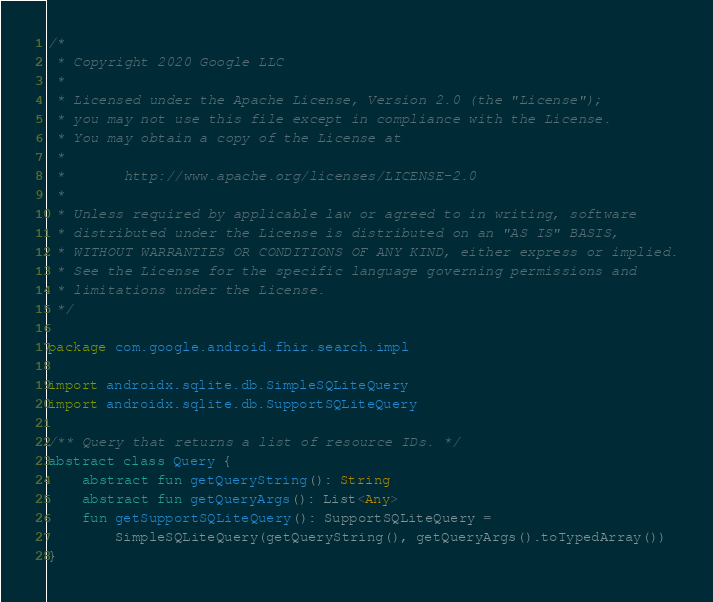Convert code to text. <code><loc_0><loc_0><loc_500><loc_500><_Kotlin_>/*
 * Copyright 2020 Google LLC
 *
 * Licensed under the Apache License, Version 2.0 (the "License");
 * you may not use this file except in compliance with the License.
 * You may obtain a copy of the License at
 *
 *       http://www.apache.org/licenses/LICENSE-2.0
 *
 * Unless required by applicable law or agreed to in writing, software
 * distributed under the License is distributed on an "AS IS" BASIS,
 * WITHOUT WARRANTIES OR CONDITIONS OF ANY KIND, either express or implied.
 * See the License for the specific language governing permissions and
 * limitations under the License.
 */

package com.google.android.fhir.search.impl

import androidx.sqlite.db.SimpleSQLiteQuery
import androidx.sqlite.db.SupportSQLiteQuery

/** Query that returns a list of resource IDs. */
abstract class Query {
    abstract fun getQueryString(): String
    abstract fun getQueryArgs(): List<Any>
    fun getSupportSQLiteQuery(): SupportSQLiteQuery =
        SimpleSQLiteQuery(getQueryString(), getQueryArgs().toTypedArray())
}
</code> 